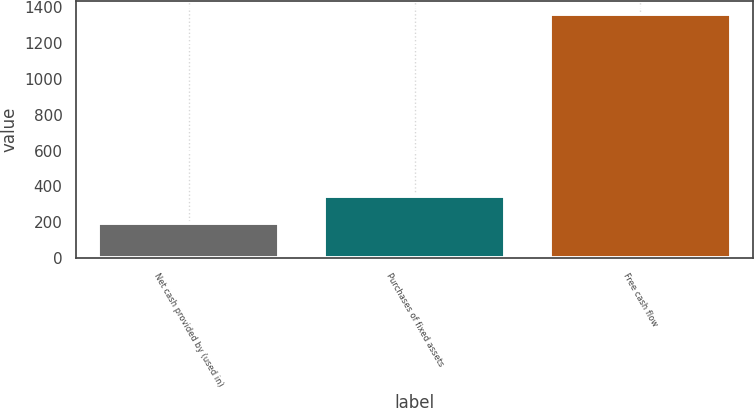<chart> <loc_0><loc_0><loc_500><loc_500><bar_chart><fcel>Net cash provided by (used in)<fcel>Purchases of fixed assets<fcel>Free cash flow<nl><fcel>198<fcel>347.9<fcel>1364<nl></chart> 